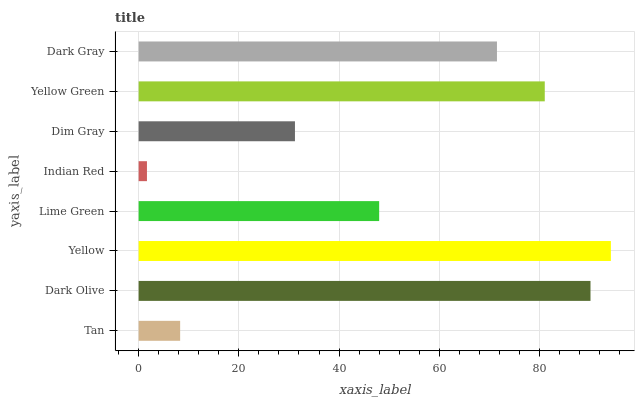Is Indian Red the minimum?
Answer yes or no. Yes. Is Yellow the maximum?
Answer yes or no. Yes. Is Dark Olive the minimum?
Answer yes or no. No. Is Dark Olive the maximum?
Answer yes or no. No. Is Dark Olive greater than Tan?
Answer yes or no. Yes. Is Tan less than Dark Olive?
Answer yes or no. Yes. Is Tan greater than Dark Olive?
Answer yes or no. No. Is Dark Olive less than Tan?
Answer yes or no. No. Is Dark Gray the high median?
Answer yes or no. Yes. Is Lime Green the low median?
Answer yes or no. Yes. Is Yellow Green the high median?
Answer yes or no. No. Is Tan the low median?
Answer yes or no. No. 